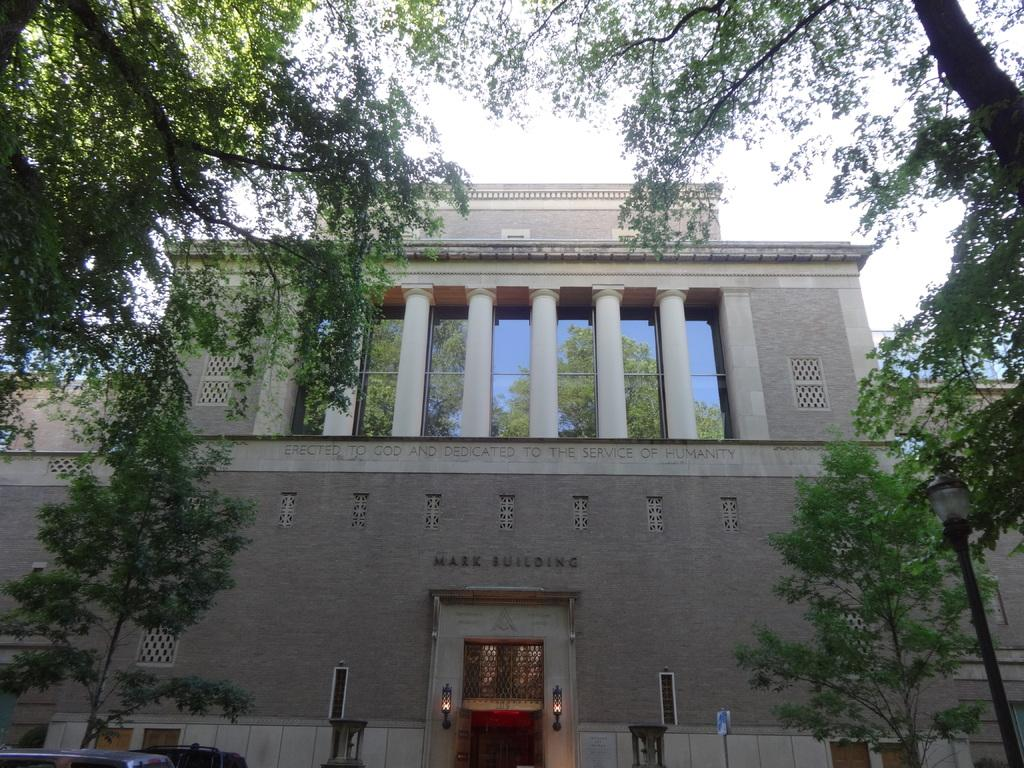What type of structure is visible in the image? There is a building in the image. What can be seen in the background of the image? There are trees in the image. What is located in front of the building? There are vehicles in front of the building. What type of breakfast is being served to the group in the image? There is no group or breakfast present in the image. The image only shows a building, trees, and vehicles. 